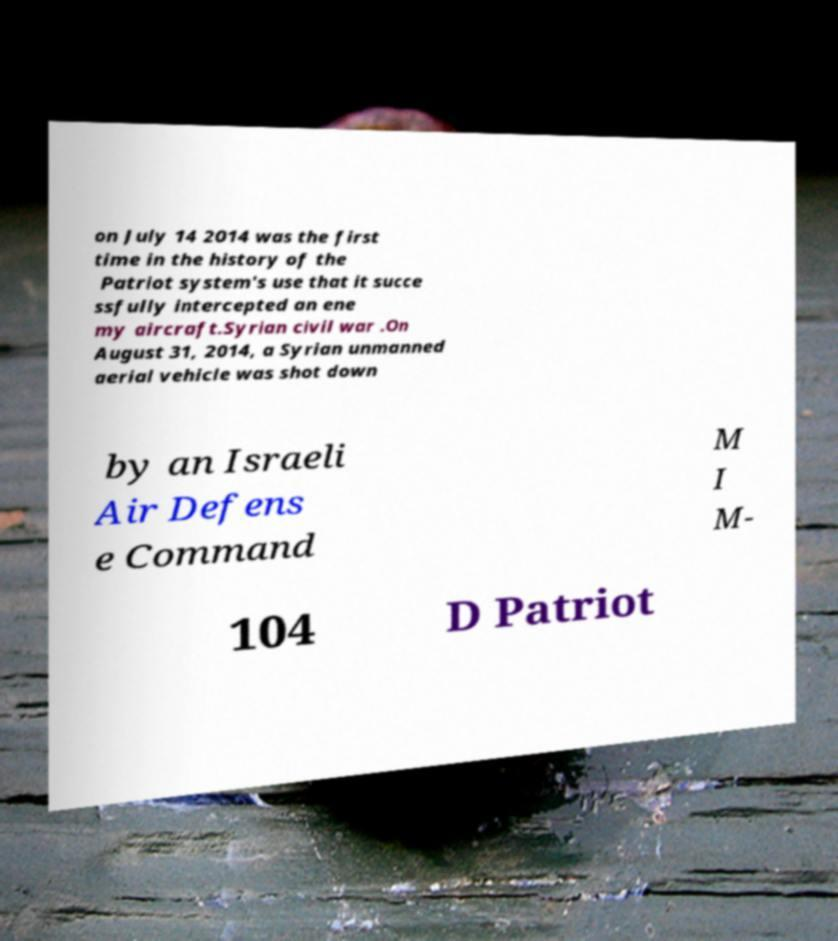What messages or text are displayed in this image? I need them in a readable, typed format. on July 14 2014 was the first time in the history of the Patriot system's use that it succe ssfully intercepted an ene my aircraft.Syrian civil war .On August 31, 2014, a Syrian unmanned aerial vehicle was shot down by an Israeli Air Defens e Command M I M- 104 D Patriot 